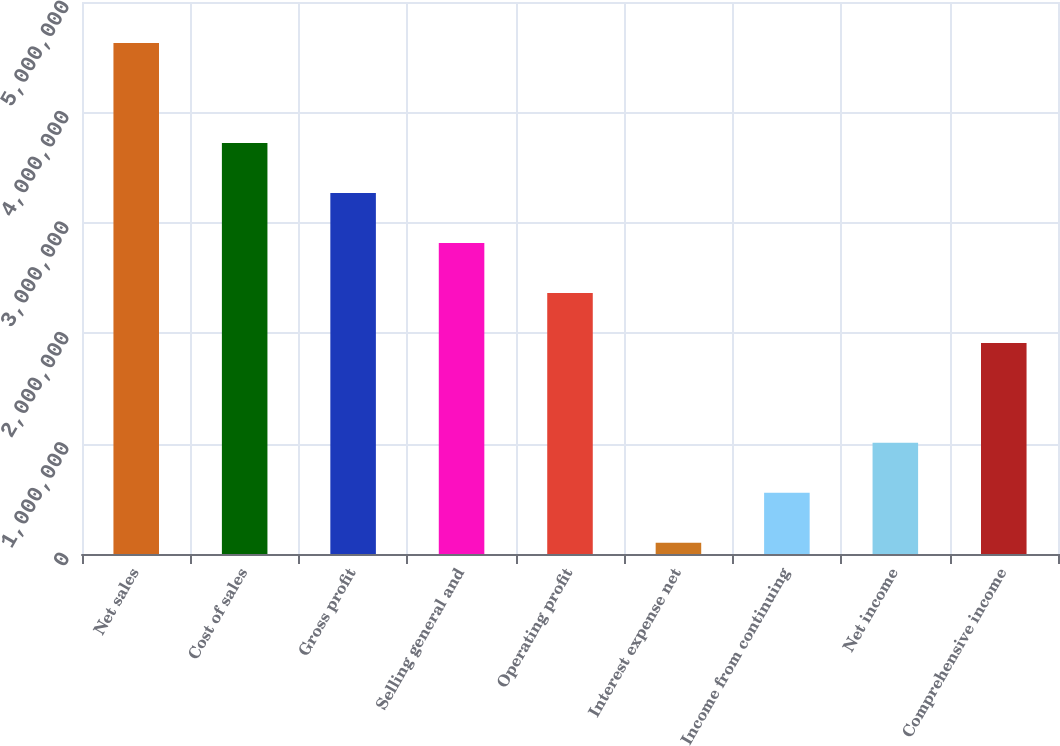Convert chart. <chart><loc_0><loc_0><loc_500><loc_500><bar_chart><fcel>Net sales<fcel>Cost of sales<fcel>Gross profit<fcel>Selling general and<fcel>Operating profit<fcel>Interest expense net<fcel>Income from continuing<fcel>Net income<fcel>Comprehensive income<nl><fcel>4.6278e+06<fcel>3.72262e+06<fcel>3.27003e+06<fcel>2.81743e+06<fcel>2.36484e+06<fcel>101884<fcel>554476<fcel>1.00707e+06<fcel>1.91225e+06<nl></chart> 